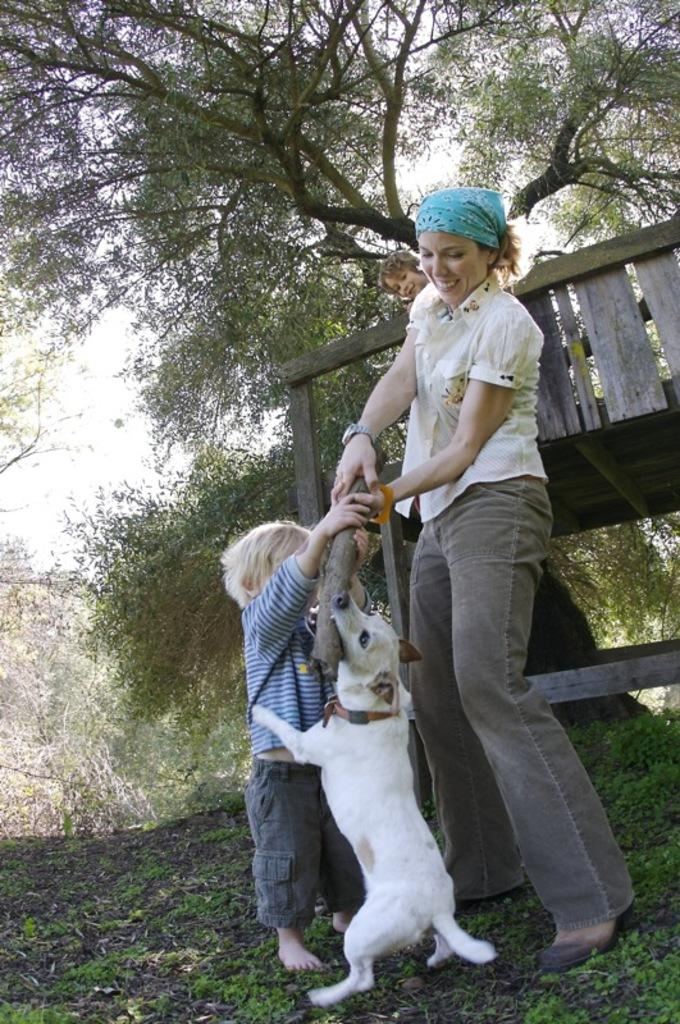Who is present in the image? There is a woman in the image. What action is being depicted in the image? There is a kiss depicted in the image. What other living creature is present in the image? There is a dog in the image. What type of natural environment is visible in the background of the image? There are trees in the background of the image. What type of ground is visible at the bottom of the image? There is grass at the bottom of the image. What type of glue is being used to hold the stage together in the image? There is no stage or glue present in the image. What is the limit of the woman's patience in the image? The image does not provide information about the woman's patience or any limits she may have. 